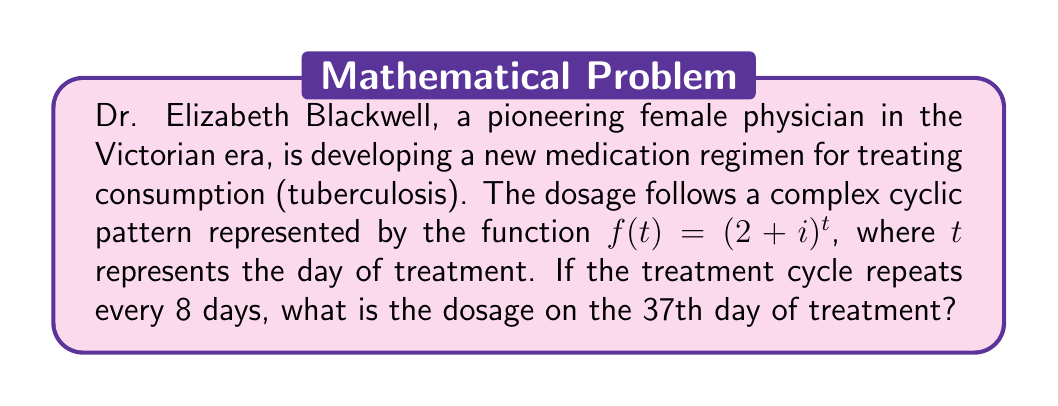Give your solution to this math problem. To solve this problem, we'll use De Moivre's theorem and the properties of complex numbers:

1) First, we need to express $(2+i)$ in polar form:
   $r = \sqrt{2^2 + 1^2} = \sqrt{5}$
   $\theta = \arctan(\frac{1}{2}) \approx 0.4636$ radians

   So, $2+i = \sqrt{5}(\cos(0.4636) + i\sin(0.4636))$

2) The cycle repeats every 8 days, so we can use modular arithmetic:
   $37 \equiv 5 \pmod{8}$

3) Now we can apply De Moivre's theorem:
   $f(37) = (2+i)^{37} = (2+i)^5$
   
   $= (\sqrt{5})^5 (\cos(5 \cdot 0.4636) + i\sin(5 \cdot 0.4636))$

4) Simplify:
   $= 5\sqrt{5} (\cos(2.318) + i\sin(2.318))$

5) Convert back to rectangular form:
   $= 5\sqrt{5} (\cos(2.318)) + i(5\sqrt{5} \sin(2.318))$
   $\approx 7.694 + 8.155i$

Therefore, on the 37th day, the dosage is represented by the complex number $7.694 + 8.155i$.
Answer: $7.694 + 8.155i$ 